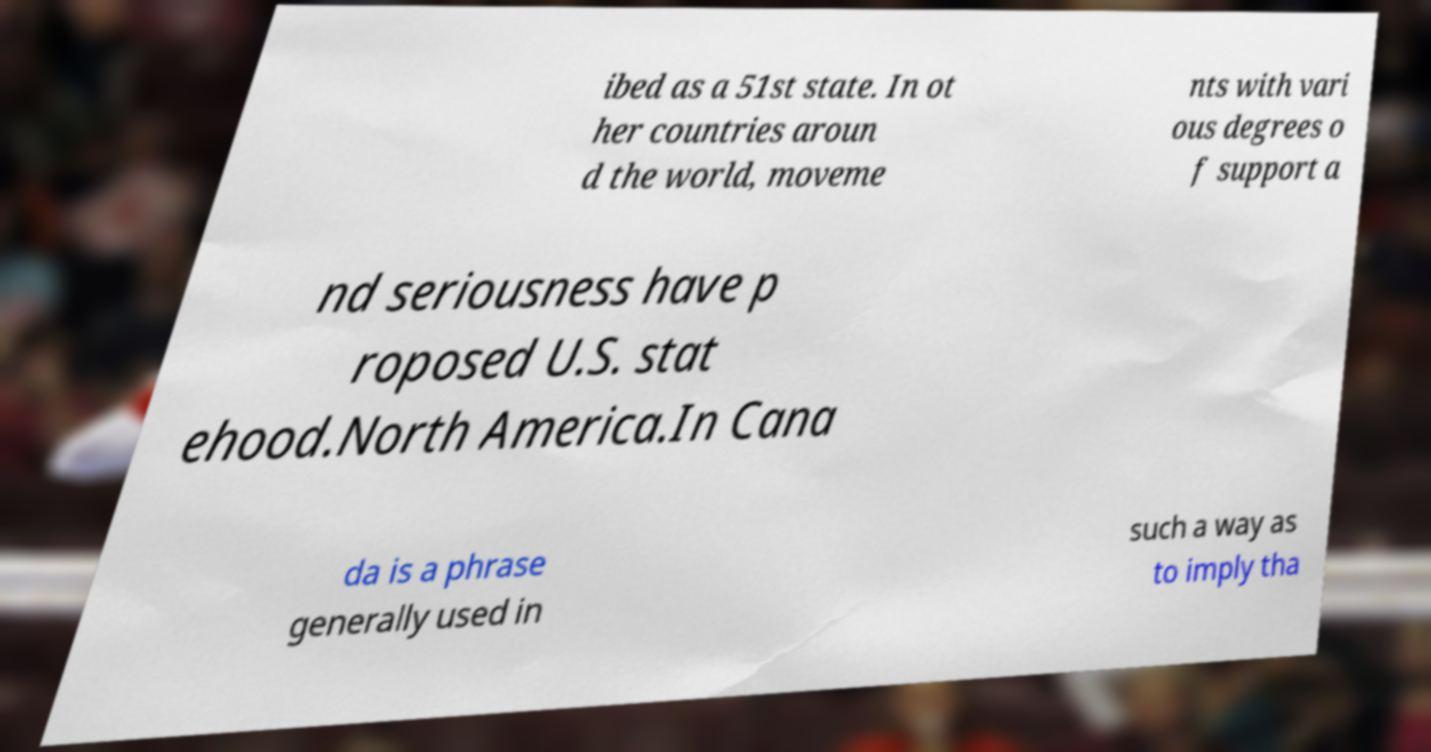What messages or text are displayed in this image? I need them in a readable, typed format. ibed as a 51st state. In ot her countries aroun d the world, moveme nts with vari ous degrees o f support a nd seriousness have p roposed U.S. stat ehood.North America.In Cana da is a phrase generally used in such a way as to imply tha 